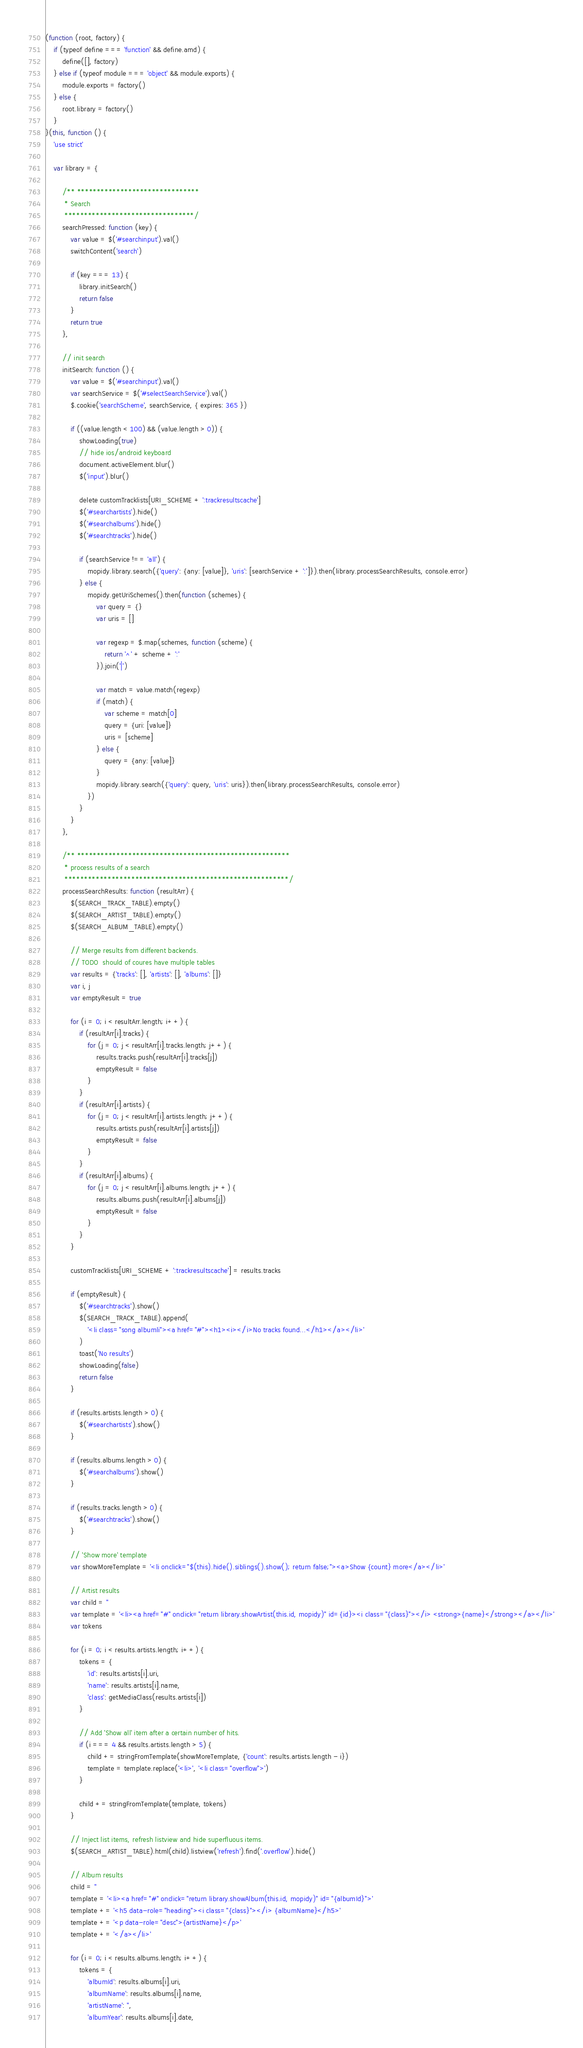<code> <loc_0><loc_0><loc_500><loc_500><_JavaScript_>(function (root, factory) {
    if (typeof define === 'function' && define.amd) {
        define([], factory)
    } else if (typeof module === 'object' && module.exports) {
        module.exports = factory()
    } else {
        root.library = factory()
    }
}(this, function () {
    'use strict'

    var library = {

        /** *******************************
         * Search
         *********************************/
        searchPressed: function (key) {
            var value = $('#searchinput').val()
            switchContent('search')

            if (key === 13) {
                library.initSearch()
                return false
            }
            return true
        },

        // init search
        initSearch: function () {
            var value = $('#searchinput').val()
            var searchService = $('#selectSearchService').val()
            $.cookie('searchScheme', searchService, { expires: 365 })

            if ((value.length < 100) && (value.length > 0)) {
                showLoading(true)
                // hide ios/android keyboard
                document.activeElement.blur()
                $('input').blur()

                delete customTracklists[URI_SCHEME + ':trackresultscache']
                $('#searchartists').hide()
                $('#searchalbums').hide()
                $('#searchtracks').hide()

                if (searchService !== 'all') {
                    mopidy.library.search({'query': {any: [value]}, 'uris': [searchService + ':']}).then(library.processSearchResults, console.error)
                } else {
                    mopidy.getUriSchemes().then(function (schemes) {
                        var query = {}
                        var uris = []

                        var regexp = $.map(schemes, function (scheme) {
                            return '^' + scheme + ':'
                        }).join('|')

                        var match = value.match(regexp)
                        if (match) {
                            var scheme = match[0]
                            query = {uri: [value]}
                            uris = [scheme]
                        } else {
                            query = {any: [value]}
                        }
                        mopidy.library.search({'query': query, 'uris': uris}).then(library.processSearchResults, console.error)
                    })
                }
            }
        },

        /** ******************************************************
         * process results of a search
         *********************************************************/
        processSearchResults: function (resultArr) {
            $(SEARCH_TRACK_TABLE).empty()
            $(SEARCH_ARTIST_TABLE).empty()
            $(SEARCH_ALBUM_TABLE).empty()

            // Merge results from different backends.
            // TODO  should of coures have multiple tables
            var results = {'tracks': [], 'artists': [], 'albums': []}
            var i, j
            var emptyResult = true

            for (i = 0; i < resultArr.length; i++) {
                if (resultArr[i].tracks) {
                    for (j = 0; j < resultArr[i].tracks.length; j++) {
                        results.tracks.push(resultArr[i].tracks[j])
                        emptyResult = false
                    }
                }
                if (resultArr[i].artists) {
                    for (j = 0; j < resultArr[i].artists.length; j++) {
                        results.artists.push(resultArr[i].artists[j])
                        emptyResult = false
                    }
                }
                if (resultArr[i].albums) {
                    for (j = 0; j < resultArr[i].albums.length; j++) {
                        results.albums.push(resultArr[i].albums[j])
                        emptyResult = false
                    }
                }
            }

            customTracklists[URI_SCHEME + ':trackresultscache'] = results.tracks

            if (emptyResult) {
                $('#searchtracks').show()
                $(SEARCH_TRACK_TABLE).append(
                    '<li class="song albumli"><a href="#"><h1><i></i>No tracks found...</h1></a></li>'
                )
                toast('No results')
                showLoading(false)
                return false
            }

            if (results.artists.length > 0) {
                $('#searchartists').show()
            }

            if (results.albums.length > 0) {
                $('#searchalbums').show()
            }

            if (results.tracks.length > 0) {
                $('#searchtracks').show()
            }

            // 'Show more' template
            var showMoreTemplate = '<li onclick="$(this).hide().siblings().show(); return false;"><a>Show {count} more</a></li>'

            // Artist results
            var child = ''
            var template = '<li><a href="#" onclick="return library.showArtist(this.id, mopidy)" id={id}><i class="{class}"></i> <strong>{name}</strong></a></li>'
            var tokens

            for (i = 0; i < results.artists.length; i++) {
                tokens = {
                    'id': results.artists[i].uri,
                    'name': results.artists[i].name,
                    'class': getMediaClass(results.artists[i])
                }

                // Add 'Show all' item after a certain number of hits.
                if (i === 4 && results.artists.length > 5) {
                    child += stringFromTemplate(showMoreTemplate, {'count': results.artists.length - i})
                    template = template.replace('<li>', '<li class="overflow">')
                }

                child += stringFromTemplate(template, tokens)
            }

            // Inject list items, refresh listview and hide superfluous items.
            $(SEARCH_ARTIST_TABLE).html(child).listview('refresh').find('.overflow').hide()

            // Album results
            child = ''
            template = '<li><a href="#" onclick="return library.showAlbum(this.id, mopidy)" id="{albumId}">'
            template += '<h5 data-role="heading"><i class="{class}"></i> {albumName}</h5>'
            template += '<p data-role="desc">{artistName}</p>'
            template += '</a></li>'

            for (i = 0; i < results.albums.length; i++) {
                tokens = {
                    'albumId': results.albums[i].uri,
                    'albumName': results.albums[i].name,
                    'artistName': '',
                    'albumYear': results.albums[i].date,</code> 